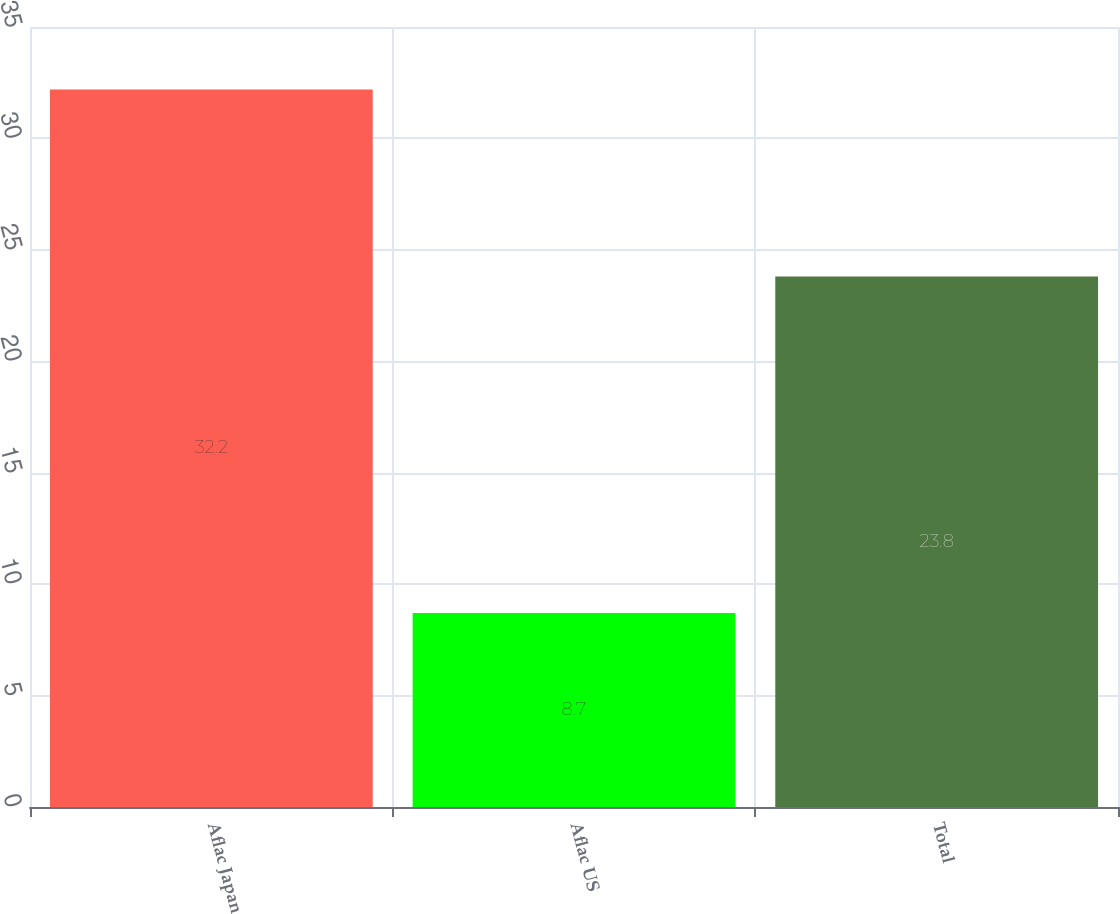<chart> <loc_0><loc_0><loc_500><loc_500><bar_chart><fcel>Aflac Japan<fcel>Aflac US<fcel>Total<nl><fcel>32.2<fcel>8.7<fcel>23.8<nl></chart> 